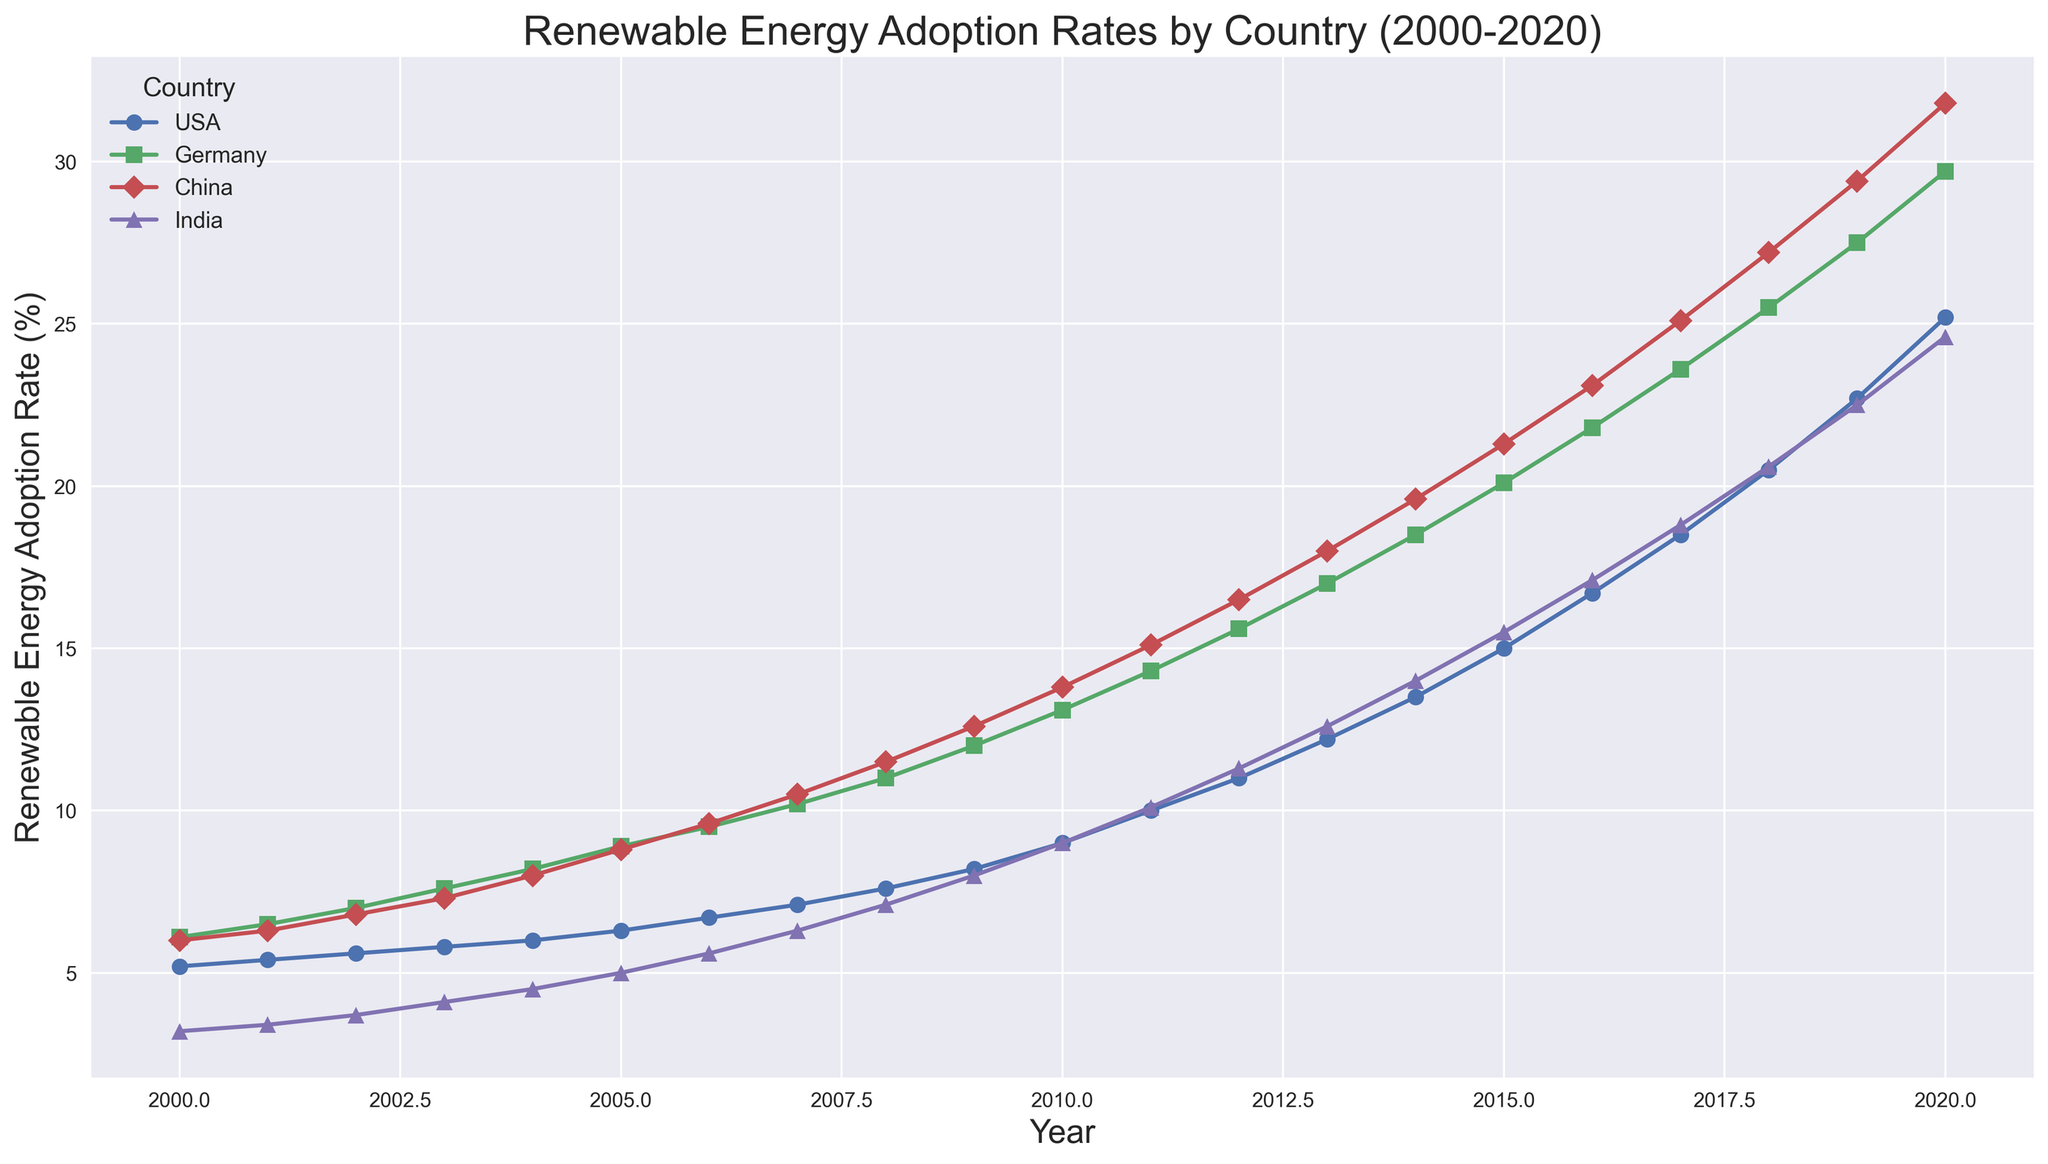Which country had the highest renewable energy adoption rate in 2020? First, identify the adoption rates for each country in 2020 from the figure. China had the highest rate at 31.8%.
Answer: China How much did the renewable energy adoption rate increase in the USA from 2000 to 2020? Check the USA's adoption rates in 2000 (5.2%) and 2020 (25.2%). The increase is 25.2% - 5.2% = 20%.
Answer: 20% Between 2010 and 2020, which country had the largest increase in adoption rate? Calculate the increase for each country from 2010 to 2020. USA: 25.2%-9%=16.2%, Germany: 29.7%-13.1%=16.6%, China: 31.8%-13.8%=18%, India: 24.6%-9%=15.6%. China had the largest increase of 18%.
Answer: China In which year did Germany’s renewable adoption rate surpass 20%? Look at the points for Germany on the plot, noting when the rate exceeds 20%. In 2015, the rate is 20.1%, so it surpasses 20% in 2015.
Answer: 2015 Among the four countries, which one had the steadiest growth in renewable energy adoption from 2000 to 2020? Observe the smoothness and consistency of the lines for each country. USA shows gradual, consistent growth without sharp increases or drops, indicating the steadiest growth.
Answer: USA 